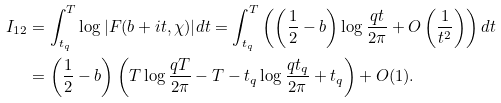Convert formula to latex. <formula><loc_0><loc_0><loc_500><loc_500>I _ { 1 2 } & = \int _ { t _ { q } } ^ { T } \log { | F ( b + i t , \chi ) | } d t = \int _ { t _ { q } } ^ { T } \left ( \left ( \frac { 1 } { 2 } - b \right ) \log { \frac { q t } { 2 \pi } } + O \left ( \frac { 1 } { t ^ { 2 } } \right ) \right ) d t \\ & = \left ( \frac { 1 } { 2 } - b \right ) \left ( T \log { \frac { q T } { 2 \pi } } - T - t _ { q } \log { \frac { q t _ { q } } { 2 \pi } } + t _ { q } \right ) + O ( 1 ) .</formula> 